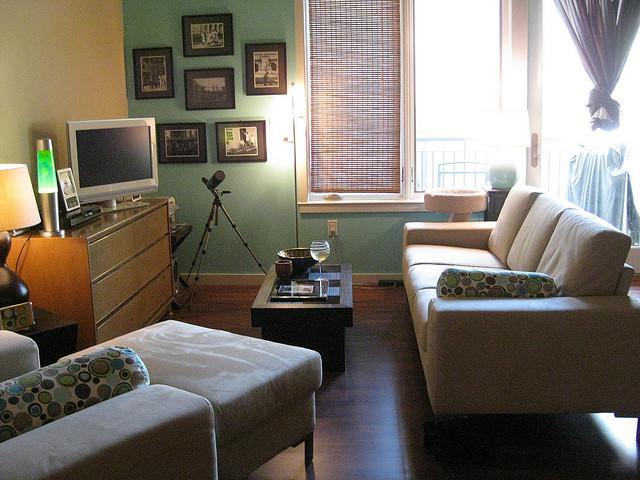How many photos are on the green wall?
Give a very brief answer. 6. How many couches are visible?
Give a very brief answer. 3. 